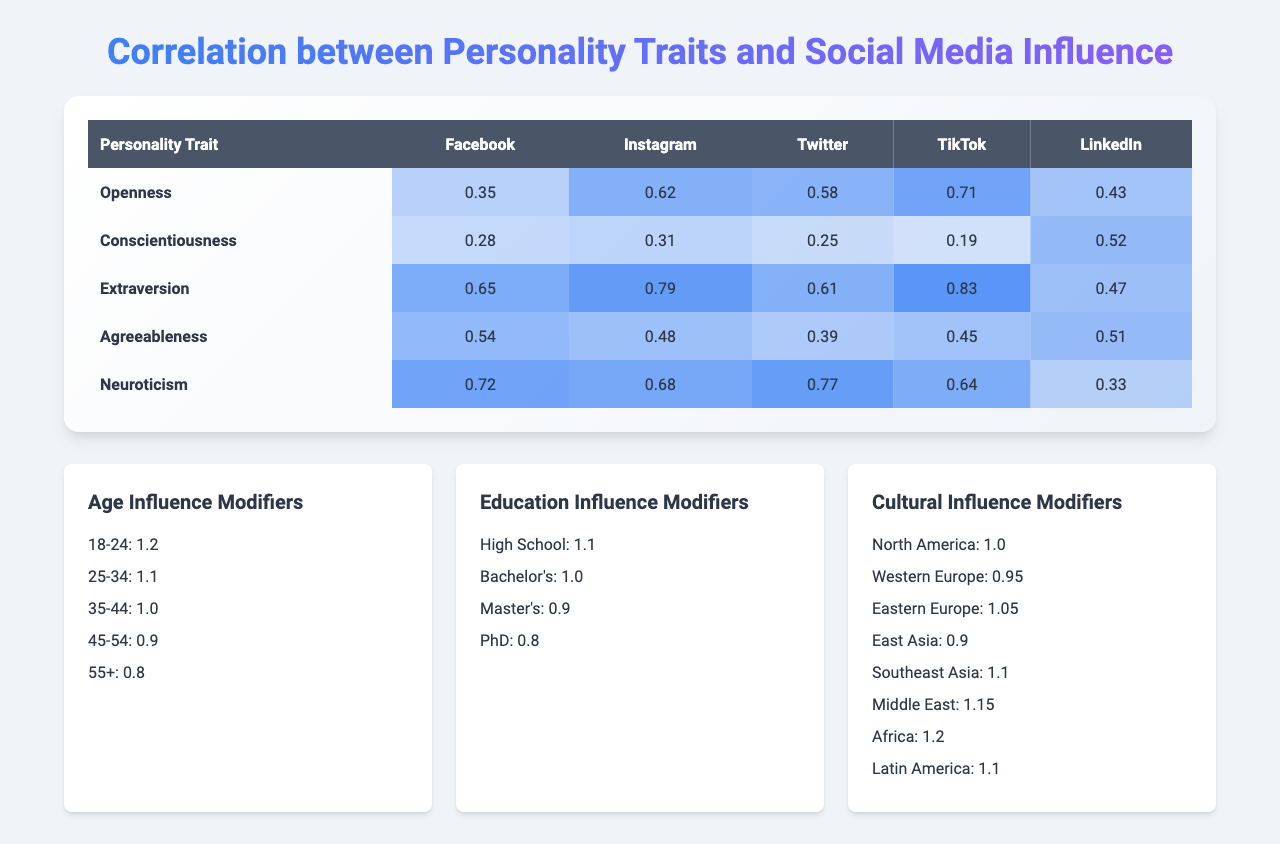What is the influence score of Neuroticism on Instagram? The influence score of Neuroticism on Instagram is found under the Neuroticism row and Instagram column in the table. The score is 0.68.
Answer: 0.68 Which social media platform shows the highest influence score for Extraversion? To find this, look at the Extraversion row and compare the scores across all platforms. TikTok has the highest score of 0.83.
Answer: TikTok What is the average influence score of Openness across all social media platforms? The influence scores for Openness are: Facebook (0.35), Instagram (0.62), Twitter (0.58), TikTok (0.71), and LinkedIn (0.43). The average is calculated as (0.35 + 0.62 + 0.58 + 0.71 + 0.43) / 5 = 0.474.
Answer: 0.474 On which platform is Agreeableness least susceptible to influence? The least susceptible score for Agreeableness is found by checking the row and identifying the lowest value. On Twitter, the score is 0.39.
Answer: Twitter Does Conscientiousness have a higher influence score on LinkedIn than on TikTok? The influence score for Conscientiousness on LinkedIn is 0.52 and on TikTok is 0.19. Since 0.52 is greater than 0.19, the statement is true.
Answer: Yes What is the sum of the influence scores for Neuroticism across all platforms? The scores for Neuroticism are: Facebook (0.72), Instagram (0.68), Twitter (0.77), TikTok (0.64), and LinkedIn (0.33). Summing these gives 0.72 + 0.68 + 0.77 + 0.64 + 0.33 = 3.14.
Answer: 3.14 Which personality trait is least influenced by social media on average, and what is that average score? Calculate the average influence score for each trait and compare them. Conscientiousness: (0.28 + 0.31 + 0.25 + 0.19 + 0.52) / 5 = 0.31 is the lowest among all.
Answer: Conscientiousness, 0.31 Is the influence score of Extraversion on Facebook greater than that of Agreeableness on LinkedIn? Extraversion on Facebook has a score of 0.65, while Agreeableness on LinkedIn has 0.51. Comparing these values shows that 0.65 is greater than 0.51. Therefore, the statement is true.
Answer: Yes What is the difference in influence scores between Openness on Instagram and Conscientiousness on LinkedIn? Openness on Instagram has a score of 0.62 and Conscientiousness on LinkedIn has 0.52. The difference is 0.62 - 0.52 = 0.10.
Answer: 0.10 How does the influence score of TikTok for Neuroticism compare to that for Openness? The influence score for TikTok under Neuroticism is 0.64, and for Openness it is 0.71. Since 0.64 is less than 0.71, Neuroticism scores lower on TikTok compared to Openness.
Answer: Lower 